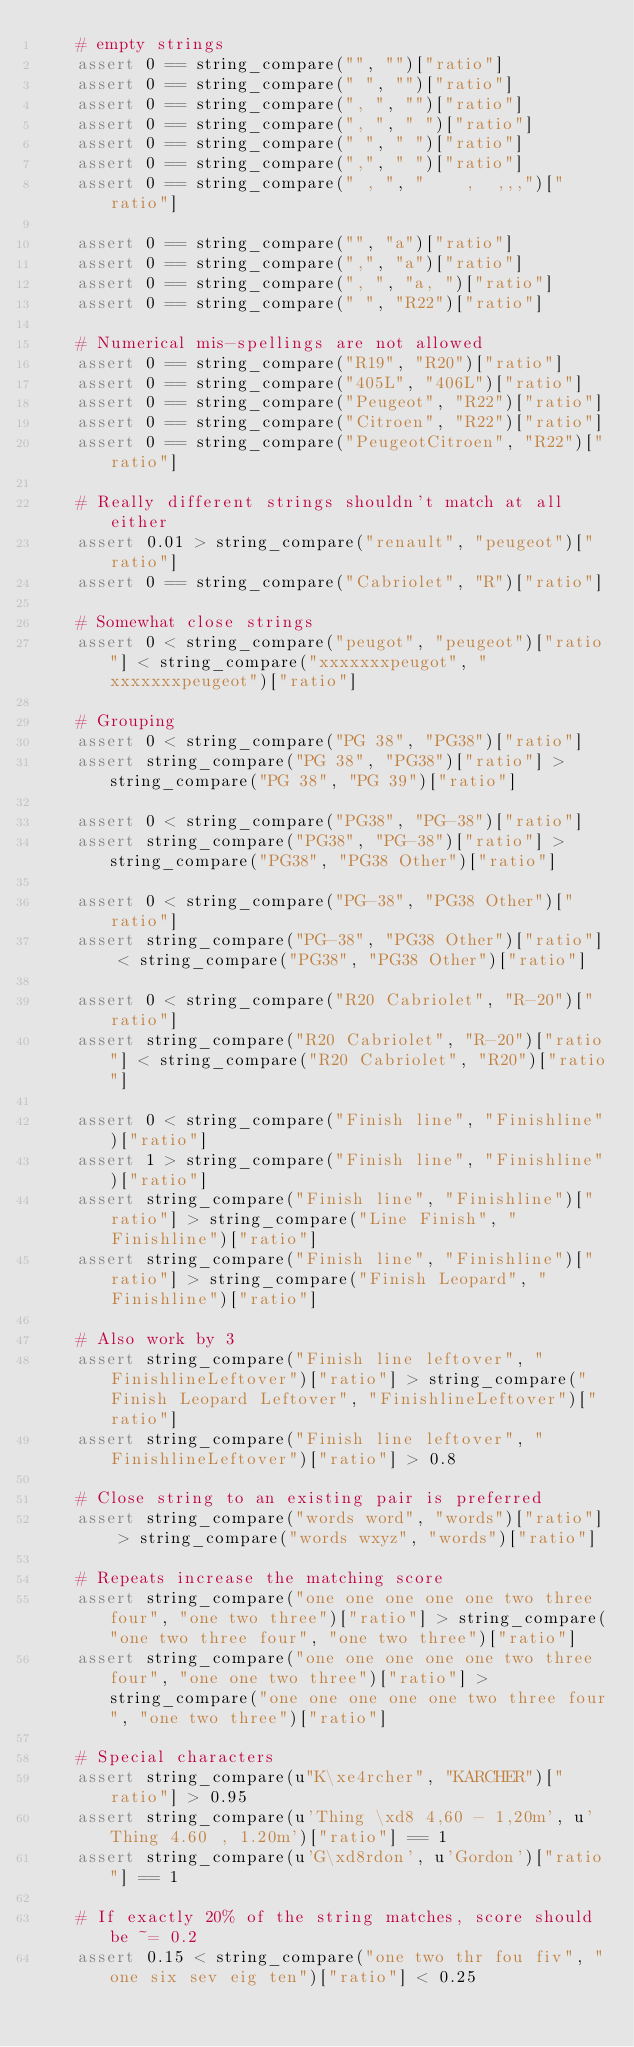Convert code to text. <code><loc_0><loc_0><loc_500><loc_500><_Python_>    # empty strings
    assert 0 == string_compare("", "")["ratio"]
    assert 0 == string_compare(" ", "")["ratio"]
    assert 0 == string_compare(", ", "")["ratio"]
    assert 0 == string_compare(", ", " ")["ratio"]
    assert 0 == string_compare(" ", " ")["ratio"]
    assert 0 == string_compare(",", " ")["ratio"]
    assert 0 == string_compare(" , ", "    ,  ,,,")["ratio"]

    assert 0 == string_compare("", "a")["ratio"]
    assert 0 == string_compare(",", "a")["ratio"]
    assert 0 == string_compare(", ", "a, ")["ratio"]
    assert 0 == string_compare(" ", "R22")["ratio"]

    # Numerical mis-spellings are not allowed
    assert 0 == string_compare("R19", "R20")["ratio"]
    assert 0 == string_compare("405L", "406L")["ratio"]
    assert 0 == string_compare("Peugeot", "R22")["ratio"]
    assert 0 == string_compare("Citroen", "R22")["ratio"]
    assert 0 == string_compare("PeugeotCitroen", "R22")["ratio"]

    # Really different strings shouldn't match at all either
    assert 0.01 > string_compare("renault", "peugeot")["ratio"]
    assert 0 == string_compare("Cabriolet", "R")["ratio"]

    # Somewhat close strings
    assert 0 < string_compare("peugot", "peugeot")["ratio"] < string_compare("xxxxxxxpeugot", "xxxxxxxpeugeot")["ratio"]

    # Grouping
    assert 0 < string_compare("PG 38", "PG38")["ratio"]
    assert string_compare("PG 38", "PG38")["ratio"] > string_compare("PG 38", "PG 39")["ratio"]

    assert 0 < string_compare("PG38", "PG-38")["ratio"]
    assert string_compare("PG38", "PG-38")["ratio"] > string_compare("PG38", "PG38 Other")["ratio"]

    assert 0 < string_compare("PG-38", "PG38 Other")["ratio"]
    assert string_compare("PG-38", "PG38 Other")["ratio"] < string_compare("PG38", "PG38 Other")["ratio"]

    assert 0 < string_compare("R20 Cabriolet", "R-20")["ratio"]
    assert string_compare("R20 Cabriolet", "R-20")["ratio"] < string_compare("R20 Cabriolet", "R20")["ratio"]

    assert 0 < string_compare("Finish line", "Finishline")["ratio"]
    assert 1 > string_compare("Finish line", "Finishline")["ratio"]
    assert string_compare("Finish line", "Finishline")["ratio"] > string_compare("Line Finish", "Finishline")["ratio"]
    assert string_compare("Finish line", "Finishline")["ratio"] > string_compare("Finish Leopard", "Finishline")["ratio"]

    # Also work by 3
    assert string_compare("Finish line leftover", "FinishlineLeftover")["ratio"] > string_compare("Finish Leopard Leftover", "FinishlineLeftover")["ratio"]
    assert string_compare("Finish line leftover", "FinishlineLeftover")["ratio"] > 0.8

    # Close string to an existing pair is preferred
    assert string_compare("words word", "words")["ratio"] > string_compare("words wxyz", "words")["ratio"]

    # Repeats increase the matching score
    assert string_compare("one one one one one two three four", "one two three")["ratio"] > string_compare("one two three four", "one two three")["ratio"]
    assert string_compare("one one one one one two three four", "one one two three")["ratio"] > string_compare("one one one one one two three four", "one two three")["ratio"]

    # Special characters
    assert string_compare(u"K\xe4rcher", "KARCHER")["ratio"] > 0.95
    assert string_compare(u'Thing \xd8 4,60 - 1,20m', u'Thing 4.60 , 1.20m')["ratio"] == 1
    assert string_compare(u'G\xd8rdon', u'Gordon')["ratio"] == 1

    # If exactly 20% of the string matches, score should be ~= 0.2
    assert 0.15 < string_compare("one two thr fou fiv", "one six sev eig ten")["ratio"] < 0.25
</code> 